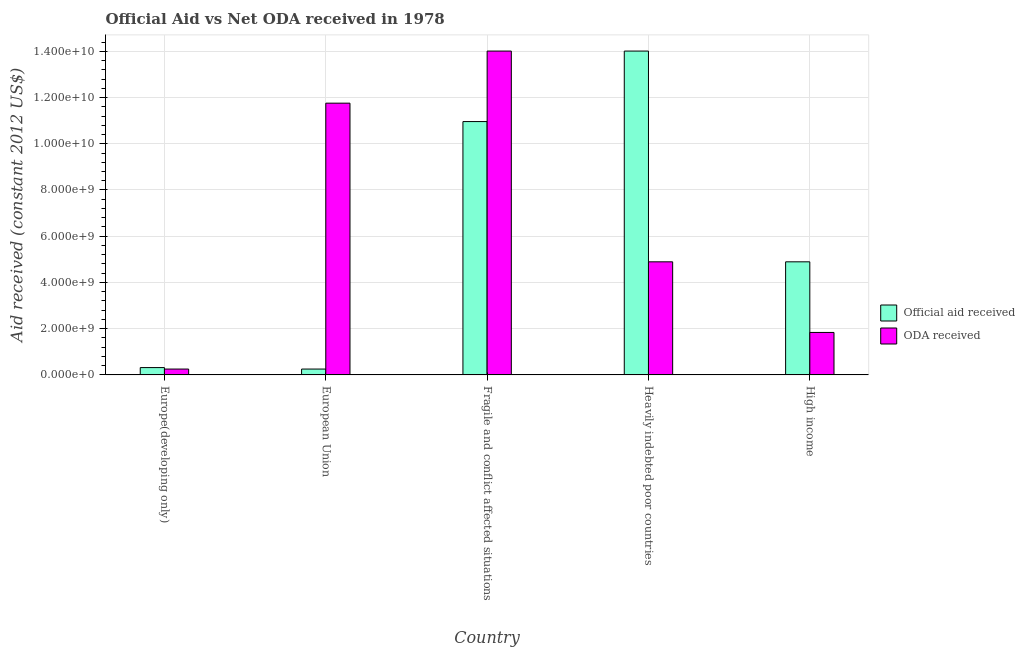How many groups of bars are there?
Ensure brevity in your answer.  5. How many bars are there on the 5th tick from the right?
Offer a terse response. 2. What is the label of the 1st group of bars from the left?
Offer a terse response. Europe(developing only). In how many cases, is the number of bars for a given country not equal to the number of legend labels?
Offer a terse response. 0. What is the oda received in Fragile and conflict affected situations?
Make the answer very short. 1.40e+1. Across all countries, what is the maximum oda received?
Make the answer very short. 1.40e+1. Across all countries, what is the minimum oda received?
Your answer should be very brief. 2.54e+08. In which country was the oda received maximum?
Give a very brief answer. Fragile and conflict affected situations. In which country was the oda received minimum?
Ensure brevity in your answer.  Europe(developing only). What is the total official aid received in the graph?
Give a very brief answer. 3.04e+1. What is the difference between the official aid received in Fragile and conflict affected situations and that in High income?
Give a very brief answer. 6.07e+09. What is the difference between the oda received in Fragile and conflict affected situations and the official aid received in Europe(developing only)?
Make the answer very short. 1.37e+1. What is the average oda received per country?
Offer a very short reply. 6.55e+09. What is the difference between the official aid received and oda received in Europe(developing only)?
Your answer should be very brief. 6.30e+07. What is the ratio of the official aid received in Heavily indebted poor countries to that in High income?
Your answer should be very brief. 2.86. Is the oda received in Europe(developing only) less than that in Fragile and conflict affected situations?
Provide a short and direct response. Yes. Is the difference between the oda received in European Union and High income greater than the difference between the official aid received in European Union and High income?
Offer a terse response. Yes. What is the difference between the highest and the second highest official aid received?
Make the answer very short. 3.05e+09. What is the difference between the highest and the lowest oda received?
Offer a terse response. 1.38e+1. What does the 2nd bar from the left in Fragile and conflict affected situations represents?
Give a very brief answer. ODA received. What does the 2nd bar from the right in Europe(developing only) represents?
Ensure brevity in your answer.  Official aid received. How many bars are there?
Offer a very short reply. 10. Are the values on the major ticks of Y-axis written in scientific E-notation?
Offer a terse response. Yes. Does the graph contain any zero values?
Your answer should be very brief. No. Does the graph contain grids?
Make the answer very short. Yes. How are the legend labels stacked?
Offer a terse response. Vertical. What is the title of the graph?
Give a very brief answer. Official Aid vs Net ODA received in 1978 . Does "Constant 2005 US$" appear as one of the legend labels in the graph?
Ensure brevity in your answer.  No. What is the label or title of the Y-axis?
Your answer should be compact. Aid received (constant 2012 US$). What is the Aid received (constant 2012 US$) in Official aid received in Europe(developing only)?
Your response must be concise. 3.17e+08. What is the Aid received (constant 2012 US$) in ODA received in Europe(developing only)?
Your answer should be compact. 2.54e+08. What is the Aid received (constant 2012 US$) of Official aid received in European Union?
Provide a short and direct response. 2.54e+08. What is the Aid received (constant 2012 US$) in ODA received in European Union?
Your answer should be very brief. 1.18e+1. What is the Aid received (constant 2012 US$) in Official aid received in Fragile and conflict affected situations?
Your response must be concise. 1.10e+1. What is the Aid received (constant 2012 US$) in ODA received in Fragile and conflict affected situations?
Offer a very short reply. 1.40e+1. What is the Aid received (constant 2012 US$) of Official aid received in Heavily indebted poor countries?
Your answer should be compact. 1.40e+1. What is the Aid received (constant 2012 US$) of ODA received in Heavily indebted poor countries?
Provide a short and direct response. 4.89e+09. What is the Aid received (constant 2012 US$) of Official aid received in High income?
Provide a succinct answer. 4.89e+09. What is the Aid received (constant 2012 US$) of ODA received in High income?
Your answer should be compact. 1.84e+09. Across all countries, what is the maximum Aid received (constant 2012 US$) in Official aid received?
Your response must be concise. 1.40e+1. Across all countries, what is the maximum Aid received (constant 2012 US$) in ODA received?
Your response must be concise. 1.40e+1. Across all countries, what is the minimum Aid received (constant 2012 US$) in Official aid received?
Provide a short and direct response. 2.54e+08. Across all countries, what is the minimum Aid received (constant 2012 US$) in ODA received?
Offer a very short reply. 2.54e+08. What is the total Aid received (constant 2012 US$) in Official aid received in the graph?
Your answer should be compact. 3.04e+1. What is the total Aid received (constant 2012 US$) in ODA received in the graph?
Give a very brief answer. 3.27e+1. What is the difference between the Aid received (constant 2012 US$) in Official aid received in Europe(developing only) and that in European Union?
Provide a short and direct response. 6.30e+07. What is the difference between the Aid received (constant 2012 US$) of ODA received in Europe(developing only) and that in European Union?
Your response must be concise. -1.15e+1. What is the difference between the Aid received (constant 2012 US$) of Official aid received in Europe(developing only) and that in Fragile and conflict affected situations?
Ensure brevity in your answer.  -1.06e+1. What is the difference between the Aid received (constant 2012 US$) in ODA received in Europe(developing only) and that in Fragile and conflict affected situations?
Give a very brief answer. -1.38e+1. What is the difference between the Aid received (constant 2012 US$) in Official aid received in Europe(developing only) and that in Heavily indebted poor countries?
Give a very brief answer. -1.37e+1. What is the difference between the Aid received (constant 2012 US$) in ODA received in Europe(developing only) and that in Heavily indebted poor countries?
Offer a very short reply. -4.64e+09. What is the difference between the Aid received (constant 2012 US$) in Official aid received in Europe(developing only) and that in High income?
Provide a short and direct response. -4.58e+09. What is the difference between the Aid received (constant 2012 US$) of ODA received in Europe(developing only) and that in High income?
Offer a terse response. -1.58e+09. What is the difference between the Aid received (constant 2012 US$) of Official aid received in European Union and that in Fragile and conflict affected situations?
Offer a very short reply. -1.07e+1. What is the difference between the Aid received (constant 2012 US$) of ODA received in European Union and that in Fragile and conflict affected situations?
Ensure brevity in your answer.  -2.25e+09. What is the difference between the Aid received (constant 2012 US$) in Official aid received in European Union and that in Heavily indebted poor countries?
Offer a very short reply. -1.38e+1. What is the difference between the Aid received (constant 2012 US$) of ODA received in European Union and that in Heavily indebted poor countries?
Give a very brief answer. 6.86e+09. What is the difference between the Aid received (constant 2012 US$) in Official aid received in European Union and that in High income?
Your answer should be very brief. -4.64e+09. What is the difference between the Aid received (constant 2012 US$) in ODA received in European Union and that in High income?
Give a very brief answer. 9.92e+09. What is the difference between the Aid received (constant 2012 US$) in Official aid received in Fragile and conflict affected situations and that in Heavily indebted poor countries?
Make the answer very short. -3.05e+09. What is the difference between the Aid received (constant 2012 US$) of ODA received in Fragile and conflict affected situations and that in Heavily indebted poor countries?
Keep it short and to the point. 9.12e+09. What is the difference between the Aid received (constant 2012 US$) of Official aid received in Fragile and conflict affected situations and that in High income?
Ensure brevity in your answer.  6.07e+09. What is the difference between the Aid received (constant 2012 US$) of ODA received in Fragile and conflict affected situations and that in High income?
Your answer should be compact. 1.22e+1. What is the difference between the Aid received (constant 2012 US$) in Official aid received in Heavily indebted poor countries and that in High income?
Provide a succinct answer. 9.12e+09. What is the difference between the Aid received (constant 2012 US$) in ODA received in Heavily indebted poor countries and that in High income?
Offer a very short reply. 3.06e+09. What is the difference between the Aid received (constant 2012 US$) in Official aid received in Europe(developing only) and the Aid received (constant 2012 US$) in ODA received in European Union?
Keep it short and to the point. -1.14e+1. What is the difference between the Aid received (constant 2012 US$) of Official aid received in Europe(developing only) and the Aid received (constant 2012 US$) of ODA received in Fragile and conflict affected situations?
Keep it short and to the point. -1.37e+1. What is the difference between the Aid received (constant 2012 US$) of Official aid received in Europe(developing only) and the Aid received (constant 2012 US$) of ODA received in Heavily indebted poor countries?
Provide a succinct answer. -4.58e+09. What is the difference between the Aid received (constant 2012 US$) of Official aid received in Europe(developing only) and the Aid received (constant 2012 US$) of ODA received in High income?
Your answer should be very brief. -1.52e+09. What is the difference between the Aid received (constant 2012 US$) of Official aid received in European Union and the Aid received (constant 2012 US$) of ODA received in Fragile and conflict affected situations?
Ensure brevity in your answer.  -1.38e+1. What is the difference between the Aid received (constant 2012 US$) of Official aid received in European Union and the Aid received (constant 2012 US$) of ODA received in Heavily indebted poor countries?
Provide a succinct answer. -4.64e+09. What is the difference between the Aid received (constant 2012 US$) of Official aid received in European Union and the Aid received (constant 2012 US$) of ODA received in High income?
Provide a short and direct response. -1.58e+09. What is the difference between the Aid received (constant 2012 US$) of Official aid received in Fragile and conflict affected situations and the Aid received (constant 2012 US$) of ODA received in Heavily indebted poor countries?
Your answer should be very brief. 6.07e+09. What is the difference between the Aid received (constant 2012 US$) of Official aid received in Fragile and conflict affected situations and the Aid received (constant 2012 US$) of ODA received in High income?
Your answer should be compact. 9.12e+09. What is the difference between the Aid received (constant 2012 US$) of Official aid received in Heavily indebted poor countries and the Aid received (constant 2012 US$) of ODA received in High income?
Give a very brief answer. 1.22e+1. What is the average Aid received (constant 2012 US$) in Official aid received per country?
Your response must be concise. 6.09e+09. What is the average Aid received (constant 2012 US$) of ODA received per country?
Provide a short and direct response. 6.55e+09. What is the difference between the Aid received (constant 2012 US$) in Official aid received and Aid received (constant 2012 US$) in ODA received in Europe(developing only)?
Provide a succinct answer. 6.30e+07. What is the difference between the Aid received (constant 2012 US$) of Official aid received and Aid received (constant 2012 US$) of ODA received in European Union?
Offer a very short reply. -1.15e+1. What is the difference between the Aid received (constant 2012 US$) of Official aid received and Aid received (constant 2012 US$) of ODA received in Fragile and conflict affected situations?
Offer a very short reply. -3.05e+09. What is the difference between the Aid received (constant 2012 US$) of Official aid received and Aid received (constant 2012 US$) of ODA received in Heavily indebted poor countries?
Make the answer very short. 9.12e+09. What is the difference between the Aid received (constant 2012 US$) in Official aid received and Aid received (constant 2012 US$) in ODA received in High income?
Provide a short and direct response. 3.06e+09. What is the ratio of the Aid received (constant 2012 US$) of Official aid received in Europe(developing only) to that in European Union?
Give a very brief answer. 1.25. What is the ratio of the Aid received (constant 2012 US$) of ODA received in Europe(developing only) to that in European Union?
Make the answer very short. 0.02. What is the ratio of the Aid received (constant 2012 US$) in Official aid received in Europe(developing only) to that in Fragile and conflict affected situations?
Offer a very short reply. 0.03. What is the ratio of the Aid received (constant 2012 US$) in ODA received in Europe(developing only) to that in Fragile and conflict affected situations?
Give a very brief answer. 0.02. What is the ratio of the Aid received (constant 2012 US$) of Official aid received in Europe(developing only) to that in Heavily indebted poor countries?
Your answer should be very brief. 0.02. What is the ratio of the Aid received (constant 2012 US$) of ODA received in Europe(developing only) to that in Heavily indebted poor countries?
Your answer should be very brief. 0.05. What is the ratio of the Aid received (constant 2012 US$) in Official aid received in Europe(developing only) to that in High income?
Keep it short and to the point. 0.06. What is the ratio of the Aid received (constant 2012 US$) of ODA received in Europe(developing only) to that in High income?
Offer a very short reply. 0.14. What is the ratio of the Aid received (constant 2012 US$) in Official aid received in European Union to that in Fragile and conflict affected situations?
Offer a very short reply. 0.02. What is the ratio of the Aid received (constant 2012 US$) in ODA received in European Union to that in Fragile and conflict affected situations?
Ensure brevity in your answer.  0.84. What is the ratio of the Aid received (constant 2012 US$) in Official aid received in European Union to that in Heavily indebted poor countries?
Give a very brief answer. 0.02. What is the ratio of the Aid received (constant 2012 US$) of ODA received in European Union to that in Heavily indebted poor countries?
Provide a succinct answer. 2.4. What is the ratio of the Aid received (constant 2012 US$) of Official aid received in European Union to that in High income?
Your answer should be compact. 0.05. What is the ratio of the Aid received (constant 2012 US$) in Official aid received in Fragile and conflict affected situations to that in Heavily indebted poor countries?
Give a very brief answer. 0.78. What is the ratio of the Aid received (constant 2012 US$) of ODA received in Fragile and conflict affected situations to that in Heavily indebted poor countries?
Your answer should be compact. 2.86. What is the ratio of the Aid received (constant 2012 US$) in Official aid received in Fragile and conflict affected situations to that in High income?
Keep it short and to the point. 2.24. What is the ratio of the Aid received (constant 2012 US$) of ODA received in Fragile and conflict affected situations to that in High income?
Keep it short and to the point. 7.63. What is the ratio of the Aid received (constant 2012 US$) in Official aid received in Heavily indebted poor countries to that in High income?
Ensure brevity in your answer.  2.86. What is the ratio of the Aid received (constant 2012 US$) in ODA received in Heavily indebted poor countries to that in High income?
Provide a succinct answer. 2.66. What is the difference between the highest and the second highest Aid received (constant 2012 US$) in Official aid received?
Offer a terse response. 3.05e+09. What is the difference between the highest and the second highest Aid received (constant 2012 US$) of ODA received?
Offer a very short reply. 2.25e+09. What is the difference between the highest and the lowest Aid received (constant 2012 US$) of Official aid received?
Your answer should be very brief. 1.38e+1. What is the difference between the highest and the lowest Aid received (constant 2012 US$) in ODA received?
Ensure brevity in your answer.  1.38e+1. 